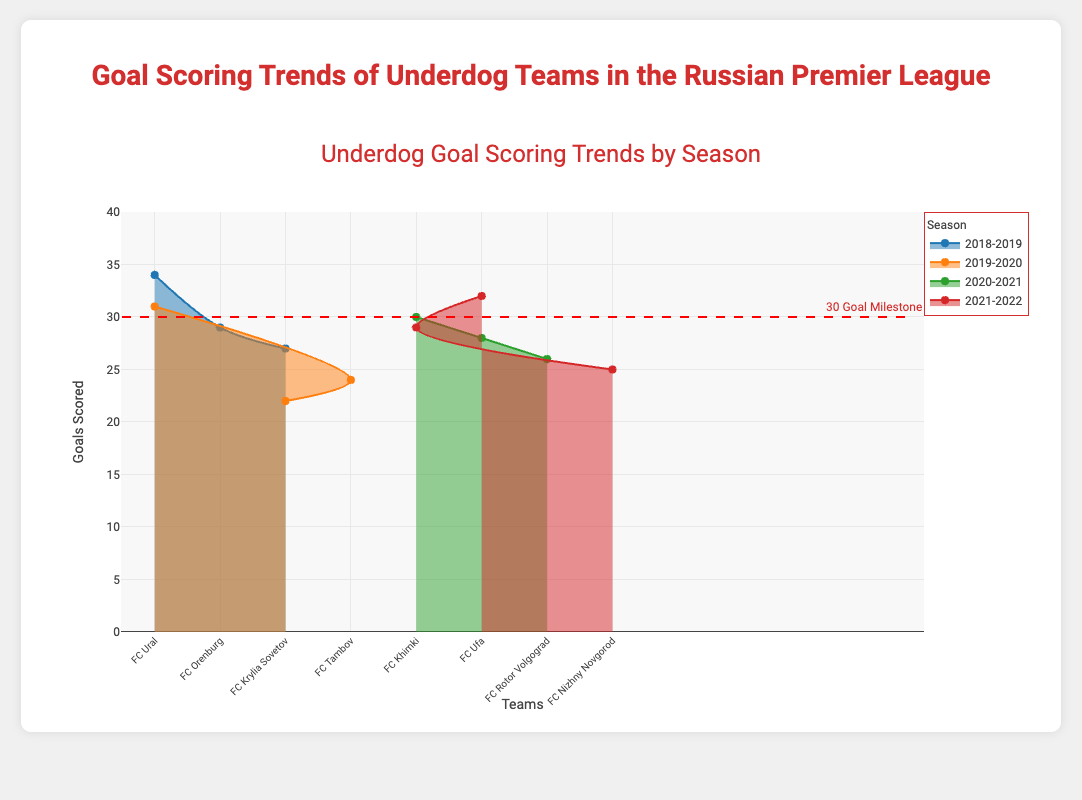What is the title of the figure? The title of the figure is typically displayed at the top and describes the main subject of the chart. In this case, it is "Goal Scoring Trends of Underdog Teams in the Russian Premier League."
Answer: Goal Scoring Trends of Underdog Teams in the Russian Premier League Which team scored the most goals in the 2018-2019 season? To find out which team scored the most goals in the 2018-2019 season, look at the data points for that season and compare the values. FC Ural scored the highest with 34 goals.
Answer: FC Ural How many seasons are represented in the chart? By reviewing the unique season labels on the x-axis or in the legend, we can count the number of distinct seasons shown in the chart. There are four seasons in total: 2018-2019, 2019-2020, 2020-2021, and 2021-2022.
Answer: 4 What is the average number of goals scored by the underdog teams in the 2020-2021 season? To calculate the average, sum the goals scored by the teams in the 2020-2021 season and divide by the number of teams: (30 + 28 + 26) / 3 = 84 / 3 = 28.
Answer: 28 Which team has the lowest goal score in the entire dataset, and how many goals is it? Look through all data points to find the team with the lowest number of goals scored. FC Krylia Sovetov scored the lowest with 22 goals in the 2019-2020 season.
Answer: FC Krylia Sovetov, 22 In the 2021-2022 season, which team is closest to the 30-goal milestone indicated in the chart, and how close were they? Compare the goal scores of the teams for the 2021-2022 season to the 30-goal milestone. FC Ufa scored 32 goals, which is 2 goals above the milestone.
Answer: FC Ufa, 2 goals above Compare the total goals scored by FC Ufa over the seasons they are represented. Is the total greater or less than 60 goals? Sum FC Ufa's goals over all seasons: 28 (2020-2021) + 32 (2021-2022) = 60. The total is exactly 60 goals.
Answer: Equal to 60 goals Between the 2019-2020 and 2021-2022 seasons, did the number of goals scored by underdog teams generally increase or decrease? By comparing the goals scored by teams in these two seasons, we can see that all teams scored more in the 2021-2022 season (32, 29, 25) compared to the 2019-2020 season (31, 24, 22). Therefore, it generally increased.
Answer: Increased What pattern is shown by the dashed red line, and what does the annotation say about it? The dashed red line is set at 30 goals on the y-axis, indicating a milestone. The annotation mentions this as the "30 Goal Milestone."
Answer: 30-goal milestone Which team scored goals in consecutive seasons, and how are their scores different between those seasons? Find a team represented in consecutive seasons and compare their goal scores. For instance, FC Ural scored 34 goals in 2018-2019 and 31 goals in 2019-2020, showing a decrease of 3 goals.
Answer: FC Ural, decreased by 3 goals 